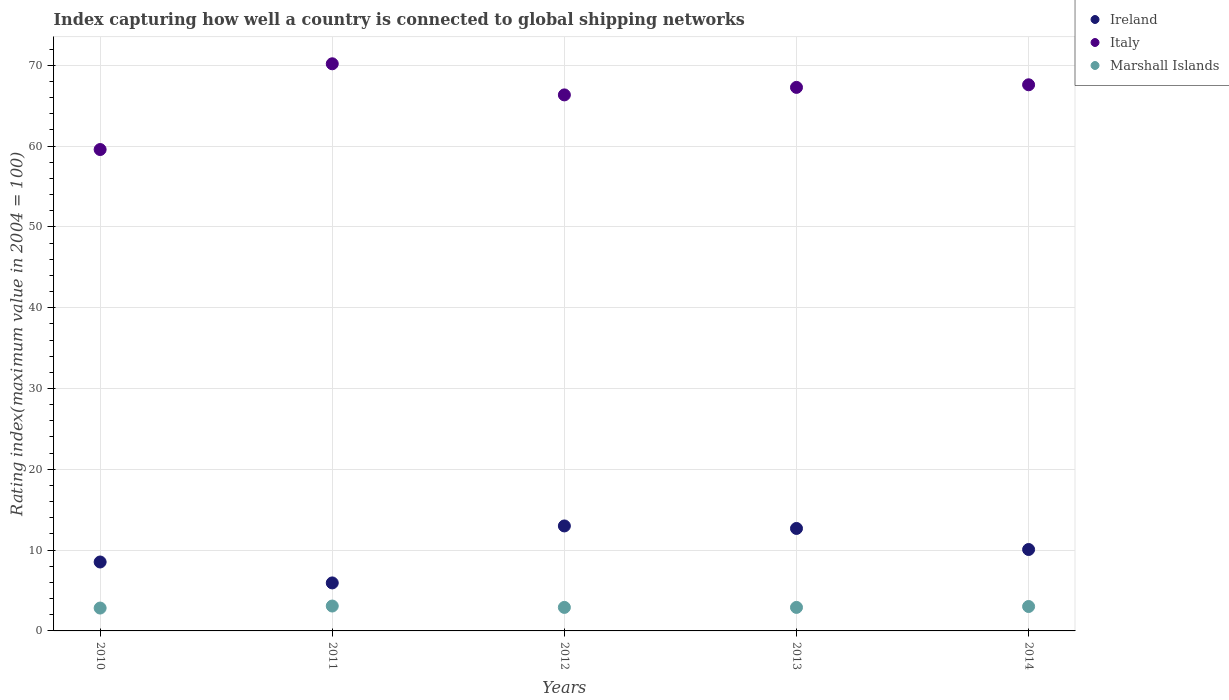Is the number of dotlines equal to the number of legend labels?
Your answer should be very brief. Yes. What is the rating index in Italy in 2014?
Keep it short and to the point. 67.58. Across all years, what is the maximum rating index in Italy?
Provide a succinct answer. 70.18. Across all years, what is the minimum rating index in Marshall Islands?
Provide a short and direct response. 2.83. What is the total rating index in Marshall Islands in the graph?
Your answer should be very brief. 14.75. What is the difference between the rating index in Marshall Islands in 2010 and that in 2013?
Give a very brief answer. -0.08. What is the difference between the rating index in Marshall Islands in 2011 and the rating index in Ireland in 2010?
Your answer should be compact. -5.45. What is the average rating index in Marshall Islands per year?
Provide a succinct answer. 2.95. In the year 2014, what is the difference between the rating index in Italy and rating index in Ireland?
Your answer should be compact. 57.51. What is the ratio of the rating index in Marshall Islands in 2012 to that in 2014?
Keep it short and to the point. 0.96. What is the difference between the highest and the second highest rating index in Italy?
Ensure brevity in your answer.  2.6. What is the difference between the highest and the lowest rating index in Ireland?
Ensure brevity in your answer.  7.05. Does the graph contain any zero values?
Your answer should be very brief. No. How many legend labels are there?
Your answer should be very brief. 3. What is the title of the graph?
Provide a short and direct response. Index capturing how well a country is connected to global shipping networks. What is the label or title of the Y-axis?
Your answer should be very brief. Rating index(maximum value in 2004 = 100). What is the Rating index(maximum value in 2004 = 100) of Ireland in 2010?
Give a very brief answer. 8.53. What is the Rating index(maximum value in 2004 = 100) of Italy in 2010?
Provide a short and direct response. 59.57. What is the Rating index(maximum value in 2004 = 100) in Marshall Islands in 2010?
Ensure brevity in your answer.  2.83. What is the Rating index(maximum value in 2004 = 100) of Ireland in 2011?
Ensure brevity in your answer.  5.94. What is the Rating index(maximum value in 2004 = 100) of Italy in 2011?
Give a very brief answer. 70.18. What is the Rating index(maximum value in 2004 = 100) of Marshall Islands in 2011?
Give a very brief answer. 3.08. What is the Rating index(maximum value in 2004 = 100) in Ireland in 2012?
Offer a terse response. 12.99. What is the Rating index(maximum value in 2004 = 100) in Italy in 2012?
Keep it short and to the point. 66.33. What is the Rating index(maximum value in 2004 = 100) of Marshall Islands in 2012?
Your answer should be compact. 2.91. What is the Rating index(maximum value in 2004 = 100) in Ireland in 2013?
Make the answer very short. 12.68. What is the Rating index(maximum value in 2004 = 100) in Italy in 2013?
Your answer should be very brief. 67.26. What is the Rating index(maximum value in 2004 = 100) in Marshall Islands in 2013?
Your answer should be compact. 2.91. What is the Rating index(maximum value in 2004 = 100) in Ireland in 2014?
Your answer should be compact. 10.08. What is the Rating index(maximum value in 2004 = 100) in Italy in 2014?
Offer a terse response. 67.58. What is the Rating index(maximum value in 2004 = 100) in Marshall Islands in 2014?
Offer a very short reply. 3.02. Across all years, what is the maximum Rating index(maximum value in 2004 = 100) in Ireland?
Your response must be concise. 12.99. Across all years, what is the maximum Rating index(maximum value in 2004 = 100) of Italy?
Offer a terse response. 70.18. Across all years, what is the maximum Rating index(maximum value in 2004 = 100) of Marshall Islands?
Offer a terse response. 3.08. Across all years, what is the minimum Rating index(maximum value in 2004 = 100) in Ireland?
Offer a very short reply. 5.94. Across all years, what is the minimum Rating index(maximum value in 2004 = 100) of Italy?
Your response must be concise. 59.57. Across all years, what is the minimum Rating index(maximum value in 2004 = 100) of Marshall Islands?
Make the answer very short. 2.83. What is the total Rating index(maximum value in 2004 = 100) in Ireland in the graph?
Provide a short and direct response. 50.22. What is the total Rating index(maximum value in 2004 = 100) in Italy in the graph?
Keep it short and to the point. 330.92. What is the total Rating index(maximum value in 2004 = 100) in Marshall Islands in the graph?
Give a very brief answer. 14.75. What is the difference between the Rating index(maximum value in 2004 = 100) of Ireland in 2010 and that in 2011?
Ensure brevity in your answer.  2.59. What is the difference between the Rating index(maximum value in 2004 = 100) in Italy in 2010 and that in 2011?
Your answer should be very brief. -10.61. What is the difference between the Rating index(maximum value in 2004 = 100) in Marshall Islands in 2010 and that in 2011?
Offer a very short reply. -0.25. What is the difference between the Rating index(maximum value in 2004 = 100) in Ireland in 2010 and that in 2012?
Your response must be concise. -4.46. What is the difference between the Rating index(maximum value in 2004 = 100) of Italy in 2010 and that in 2012?
Make the answer very short. -6.76. What is the difference between the Rating index(maximum value in 2004 = 100) of Marshall Islands in 2010 and that in 2012?
Offer a very short reply. -0.08. What is the difference between the Rating index(maximum value in 2004 = 100) of Ireland in 2010 and that in 2013?
Make the answer very short. -4.15. What is the difference between the Rating index(maximum value in 2004 = 100) of Italy in 2010 and that in 2013?
Offer a terse response. -7.69. What is the difference between the Rating index(maximum value in 2004 = 100) of Marshall Islands in 2010 and that in 2013?
Offer a very short reply. -0.08. What is the difference between the Rating index(maximum value in 2004 = 100) in Ireland in 2010 and that in 2014?
Ensure brevity in your answer.  -1.55. What is the difference between the Rating index(maximum value in 2004 = 100) of Italy in 2010 and that in 2014?
Make the answer very short. -8.01. What is the difference between the Rating index(maximum value in 2004 = 100) of Marshall Islands in 2010 and that in 2014?
Ensure brevity in your answer.  -0.19. What is the difference between the Rating index(maximum value in 2004 = 100) in Ireland in 2011 and that in 2012?
Offer a very short reply. -7.05. What is the difference between the Rating index(maximum value in 2004 = 100) of Italy in 2011 and that in 2012?
Your answer should be very brief. 3.85. What is the difference between the Rating index(maximum value in 2004 = 100) in Marshall Islands in 2011 and that in 2012?
Ensure brevity in your answer.  0.17. What is the difference between the Rating index(maximum value in 2004 = 100) of Ireland in 2011 and that in 2013?
Offer a terse response. -6.74. What is the difference between the Rating index(maximum value in 2004 = 100) of Italy in 2011 and that in 2013?
Offer a very short reply. 2.92. What is the difference between the Rating index(maximum value in 2004 = 100) in Marshall Islands in 2011 and that in 2013?
Give a very brief answer. 0.17. What is the difference between the Rating index(maximum value in 2004 = 100) in Ireland in 2011 and that in 2014?
Ensure brevity in your answer.  -4.14. What is the difference between the Rating index(maximum value in 2004 = 100) of Italy in 2011 and that in 2014?
Your answer should be very brief. 2.6. What is the difference between the Rating index(maximum value in 2004 = 100) of Marshall Islands in 2011 and that in 2014?
Offer a very short reply. 0.06. What is the difference between the Rating index(maximum value in 2004 = 100) in Ireland in 2012 and that in 2013?
Your response must be concise. 0.31. What is the difference between the Rating index(maximum value in 2004 = 100) in Italy in 2012 and that in 2013?
Make the answer very short. -0.93. What is the difference between the Rating index(maximum value in 2004 = 100) in Ireland in 2012 and that in 2014?
Provide a succinct answer. 2.91. What is the difference between the Rating index(maximum value in 2004 = 100) in Italy in 2012 and that in 2014?
Your answer should be very brief. -1.25. What is the difference between the Rating index(maximum value in 2004 = 100) of Marshall Islands in 2012 and that in 2014?
Offer a terse response. -0.11. What is the difference between the Rating index(maximum value in 2004 = 100) in Ireland in 2013 and that in 2014?
Offer a very short reply. 2.6. What is the difference between the Rating index(maximum value in 2004 = 100) of Italy in 2013 and that in 2014?
Give a very brief answer. -0.32. What is the difference between the Rating index(maximum value in 2004 = 100) of Marshall Islands in 2013 and that in 2014?
Provide a short and direct response. -0.11. What is the difference between the Rating index(maximum value in 2004 = 100) of Ireland in 2010 and the Rating index(maximum value in 2004 = 100) of Italy in 2011?
Your answer should be compact. -61.65. What is the difference between the Rating index(maximum value in 2004 = 100) of Ireland in 2010 and the Rating index(maximum value in 2004 = 100) of Marshall Islands in 2011?
Offer a terse response. 5.45. What is the difference between the Rating index(maximum value in 2004 = 100) in Italy in 2010 and the Rating index(maximum value in 2004 = 100) in Marshall Islands in 2011?
Give a very brief answer. 56.49. What is the difference between the Rating index(maximum value in 2004 = 100) of Ireland in 2010 and the Rating index(maximum value in 2004 = 100) of Italy in 2012?
Your answer should be compact. -57.8. What is the difference between the Rating index(maximum value in 2004 = 100) of Ireland in 2010 and the Rating index(maximum value in 2004 = 100) of Marshall Islands in 2012?
Provide a succinct answer. 5.62. What is the difference between the Rating index(maximum value in 2004 = 100) in Italy in 2010 and the Rating index(maximum value in 2004 = 100) in Marshall Islands in 2012?
Your response must be concise. 56.66. What is the difference between the Rating index(maximum value in 2004 = 100) in Ireland in 2010 and the Rating index(maximum value in 2004 = 100) in Italy in 2013?
Provide a succinct answer. -58.73. What is the difference between the Rating index(maximum value in 2004 = 100) of Ireland in 2010 and the Rating index(maximum value in 2004 = 100) of Marshall Islands in 2013?
Make the answer very short. 5.62. What is the difference between the Rating index(maximum value in 2004 = 100) of Italy in 2010 and the Rating index(maximum value in 2004 = 100) of Marshall Islands in 2013?
Provide a succinct answer. 56.66. What is the difference between the Rating index(maximum value in 2004 = 100) of Ireland in 2010 and the Rating index(maximum value in 2004 = 100) of Italy in 2014?
Your answer should be very brief. -59.05. What is the difference between the Rating index(maximum value in 2004 = 100) in Ireland in 2010 and the Rating index(maximum value in 2004 = 100) in Marshall Islands in 2014?
Give a very brief answer. 5.51. What is the difference between the Rating index(maximum value in 2004 = 100) in Italy in 2010 and the Rating index(maximum value in 2004 = 100) in Marshall Islands in 2014?
Your answer should be very brief. 56.55. What is the difference between the Rating index(maximum value in 2004 = 100) in Ireland in 2011 and the Rating index(maximum value in 2004 = 100) in Italy in 2012?
Your response must be concise. -60.39. What is the difference between the Rating index(maximum value in 2004 = 100) of Ireland in 2011 and the Rating index(maximum value in 2004 = 100) of Marshall Islands in 2012?
Your response must be concise. 3.03. What is the difference between the Rating index(maximum value in 2004 = 100) in Italy in 2011 and the Rating index(maximum value in 2004 = 100) in Marshall Islands in 2012?
Offer a terse response. 67.27. What is the difference between the Rating index(maximum value in 2004 = 100) in Ireland in 2011 and the Rating index(maximum value in 2004 = 100) in Italy in 2013?
Offer a terse response. -61.32. What is the difference between the Rating index(maximum value in 2004 = 100) in Ireland in 2011 and the Rating index(maximum value in 2004 = 100) in Marshall Islands in 2013?
Offer a terse response. 3.03. What is the difference between the Rating index(maximum value in 2004 = 100) in Italy in 2011 and the Rating index(maximum value in 2004 = 100) in Marshall Islands in 2013?
Ensure brevity in your answer.  67.27. What is the difference between the Rating index(maximum value in 2004 = 100) of Ireland in 2011 and the Rating index(maximum value in 2004 = 100) of Italy in 2014?
Your response must be concise. -61.64. What is the difference between the Rating index(maximum value in 2004 = 100) of Ireland in 2011 and the Rating index(maximum value in 2004 = 100) of Marshall Islands in 2014?
Your answer should be compact. 2.92. What is the difference between the Rating index(maximum value in 2004 = 100) in Italy in 2011 and the Rating index(maximum value in 2004 = 100) in Marshall Islands in 2014?
Offer a very short reply. 67.16. What is the difference between the Rating index(maximum value in 2004 = 100) in Ireland in 2012 and the Rating index(maximum value in 2004 = 100) in Italy in 2013?
Keep it short and to the point. -54.27. What is the difference between the Rating index(maximum value in 2004 = 100) in Ireland in 2012 and the Rating index(maximum value in 2004 = 100) in Marshall Islands in 2013?
Your answer should be very brief. 10.08. What is the difference between the Rating index(maximum value in 2004 = 100) of Italy in 2012 and the Rating index(maximum value in 2004 = 100) of Marshall Islands in 2013?
Your response must be concise. 63.42. What is the difference between the Rating index(maximum value in 2004 = 100) in Ireland in 2012 and the Rating index(maximum value in 2004 = 100) in Italy in 2014?
Offer a terse response. -54.59. What is the difference between the Rating index(maximum value in 2004 = 100) of Ireland in 2012 and the Rating index(maximum value in 2004 = 100) of Marshall Islands in 2014?
Your answer should be very brief. 9.97. What is the difference between the Rating index(maximum value in 2004 = 100) of Italy in 2012 and the Rating index(maximum value in 2004 = 100) of Marshall Islands in 2014?
Provide a short and direct response. 63.31. What is the difference between the Rating index(maximum value in 2004 = 100) of Ireland in 2013 and the Rating index(maximum value in 2004 = 100) of Italy in 2014?
Make the answer very short. -54.9. What is the difference between the Rating index(maximum value in 2004 = 100) in Ireland in 2013 and the Rating index(maximum value in 2004 = 100) in Marshall Islands in 2014?
Offer a very short reply. 9.66. What is the difference between the Rating index(maximum value in 2004 = 100) of Italy in 2013 and the Rating index(maximum value in 2004 = 100) of Marshall Islands in 2014?
Provide a short and direct response. 64.24. What is the average Rating index(maximum value in 2004 = 100) of Ireland per year?
Your answer should be compact. 10.04. What is the average Rating index(maximum value in 2004 = 100) of Italy per year?
Provide a short and direct response. 66.18. What is the average Rating index(maximum value in 2004 = 100) of Marshall Islands per year?
Offer a very short reply. 2.95. In the year 2010, what is the difference between the Rating index(maximum value in 2004 = 100) in Ireland and Rating index(maximum value in 2004 = 100) in Italy?
Provide a short and direct response. -51.04. In the year 2010, what is the difference between the Rating index(maximum value in 2004 = 100) of Italy and Rating index(maximum value in 2004 = 100) of Marshall Islands?
Offer a very short reply. 56.74. In the year 2011, what is the difference between the Rating index(maximum value in 2004 = 100) in Ireland and Rating index(maximum value in 2004 = 100) in Italy?
Ensure brevity in your answer.  -64.24. In the year 2011, what is the difference between the Rating index(maximum value in 2004 = 100) in Ireland and Rating index(maximum value in 2004 = 100) in Marshall Islands?
Your response must be concise. 2.86. In the year 2011, what is the difference between the Rating index(maximum value in 2004 = 100) in Italy and Rating index(maximum value in 2004 = 100) in Marshall Islands?
Provide a succinct answer. 67.1. In the year 2012, what is the difference between the Rating index(maximum value in 2004 = 100) in Ireland and Rating index(maximum value in 2004 = 100) in Italy?
Provide a short and direct response. -53.34. In the year 2012, what is the difference between the Rating index(maximum value in 2004 = 100) of Ireland and Rating index(maximum value in 2004 = 100) of Marshall Islands?
Your answer should be compact. 10.08. In the year 2012, what is the difference between the Rating index(maximum value in 2004 = 100) of Italy and Rating index(maximum value in 2004 = 100) of Marshall Islands?
Offer a terse response. 63.42. In the year 2013, what is the difference between the Rating index(maximum value in 2004 = 100) of Ireland and Rating index(maximum value in 2004 = 100) of Italy?
Your answer should be compact. -54.58. In the year 2013, what is the difference between the Rating index(maximum value in 2004 = 100) of Ireland and Rating index(maximum value in 2004 = 100) of Marshall Islands?
Provide a succinct answer. 9.77. In the year 2013, what is the difference between the Rating index(maximum value in 2004 = 100) in Italy and Rating index(maximum value in 2004 = 100) in Marshall Islands?
Keep it short and to the point. 64.35. In the year 2014, what is the difference between the Rating index(maximum value in 2004 = 100) in Ireland and Rating index(maximum value in 2004 = 100) in Italy?
Your answer should be very brief. -57.51. In the year 2014, what is the difference between the Rating index(maximum value in 2004 = 100) in Ireland and Rating index(maximum value in 2004 = 100) in Marshall Islands?
Your response must be concise. 7.05. In the year 2014, what is the difference between the Rating index(maximum value in 2004 = 100) in Italy and Rating index(maximum value in 2004 = 100) in Marshall Islands?
Ensure brevity in your answer.  64.56. What is the ratio of the Rating index(maximum value in 2004 = 100) of Ireland in 2010 to that in 2011?
Your answer should be compact. 1.44. What is the ratio of the Rating index(maximum value in 2004 = 100) in Italy in 2010 to that in 2011?
Offer a terse response. 0.85. What is the ratio of the Rating index(maximum value in 2004 = 100) of Marshall Islands in 2010 to that in 2011?
Your response must be concise. 0.92. What is the ratio of the Rating index(maximum value in 2004 = 100) of Ireland in 2010 to that in 2012?
Make the answer very short. 0.66. What is the ratio of the Rating index(maximum value in 2004 = 100) of Italy in 2010 to that in 2012?
Provide a short and direct response. 0.9. What is the ratio of the Rating index(maximum value in 2004 = 100) in Marshall Islands in 2010 to that in 2012?
Offer a terse response. 0.97. What is the ratio of the Rating index(maximum value in 2004 = 100) of Ireland in 2010 to that in 2013?
Your answer should be very brief. 0.67. What is the ratio of the Rating index(maximum value in 2004 = 100) of Italy in 2010 to that in 2013?
Provide a short and direct response. 0.89. What is the ratio of the Rating index(maximum value in 2004 = 100) of Marshall Islands in 2010 to that in 2013?
Give a very brief answer. 0.97. What is the ratio of the Rating index(maximum value in 2004 = 100) of Ireland in 2010 to that in 2014?
Your response must be concise. 0.85. What is the ratio of the Rating index(maximum value in 2004 = 100) of Italy in 2010 to that in 2014?
Your response must be concise. 0.88. What is the ratio of the Rating index(maximum value in 2004 = 100) of Marshall Islands in 2010 to that in 2014?
Provide a succinct answer. 0.94. What is the ratio of the Rating index(maximum value in 2004 = 100) of Ireland in 2011 to that in 2012?
Keep it short and to the point. 0.46. What is the ratio of the Rating index(maximum value in 2004 = 100) in Italy in 2011 to that in 2012?
Offer a very short reply. 1.06. What is the ratio of the Rating index(maximum value in 2004 = 100) in Marshall Islands in 2011 to that in 2012?
Provide a short and direct response. 1.06. What is the ratio of the Rating index(maximum value in 2004 = 100) in Ireland in 2011 to that in 2013?
Ensure brevity in your answer.  0.47. What is the ratio of the Rating index(maximum value in 2004 = 100) in Italy in 2011 to that in 2013?
Your answer should be very brief. 1.04. What is the ratio of the Rating index(maximum value in 2004 = 100) in Marshall Islands in 2011 to that in 2013?
Keep it short and to the point. 1.06. What is the ratio of the Rating index(maximum value in 2004 = 100) of Ireland in 2011 to that in 2014?
Your answer should be very brief. 0.59. What is the ratio of the Rating index(maximum value in 2004 = 100) of Italy in 2011 to that in 2014?
Provide a short and direct response. 1.04. What is the ratio of the Rating index(maximum value in 2004 = 100) of Marshall Islands in 2011 to that in 2014?
Ensure brevity in your answer.  1.02. What is the ratio of the Rating index(maximum value in 2004 = 100) of Ireland in 2012 to that in 2013?
Your answer should be very brief. 1.02. What is the ratio of the Rating index(maximum value in 2004 = 100) of Italy in 2012 to that in 2013?
Make the answer very short. 0.99. What is the ratio of the Rating index(maximum value in 2004 = 100) of Marshall Islands in 2012 to that in 2013?
Your answer should be compact. 1. What is the ratio of the Rating index(maximum value in 2004 = 100) in Ireland in 2012 to that in 2014?
Ensure brevity in your answer.  1.29. What is the ratio of the Rating index(maximum value in 2004 = 100) in Italy in 2012 to that in 2014?
Ensure brevity in your answer.  0.98. What is the ratio of the Rating index(maximum value in 2004 = 100) in Marshall Islands in 2012 to that in 2014?
Your response must be concise. 0.96. What is the ratio of the Rating index(maximum value in 2004 = 100) in Ireland in 2013 to that in 2014?
Your response must be concise. 1.26. What is the ratio of the Rating index(maximum value in 2004 = 100) in Marshall Islands in 2013 to that in 2014?
Offer a very short reply. 0.96. What is the difference between the highest and the second highest Rating index(maximum value in 2004 = 100) in Ireland?
Your response must be concise. 0.31. What is the difference between the highest and the second highest Rating index(maximum value in 2004 = 100) of Italy?
Offer a very short reply. 2.6. What is the difference between the highest and the second highest Rating index(maximum value in 2004 = 100) in Marshall Islands?
Your answer should be compact. 0.06. What is the difference between the highest and the lowest Rating index(maximum value in 2004 = 100) in Ireland?
Your answer should be very brief. 7.05. What is the difference between the highest and the lowest Rating index(maximum value in 2004 = 100) of Italy?
Offer a terse response. 10.61. What is the difference between the highest and the lowest Rating index(maximum value in 2004 = 100) of Marshall Islands?
Offer a terse response. 0.25. 